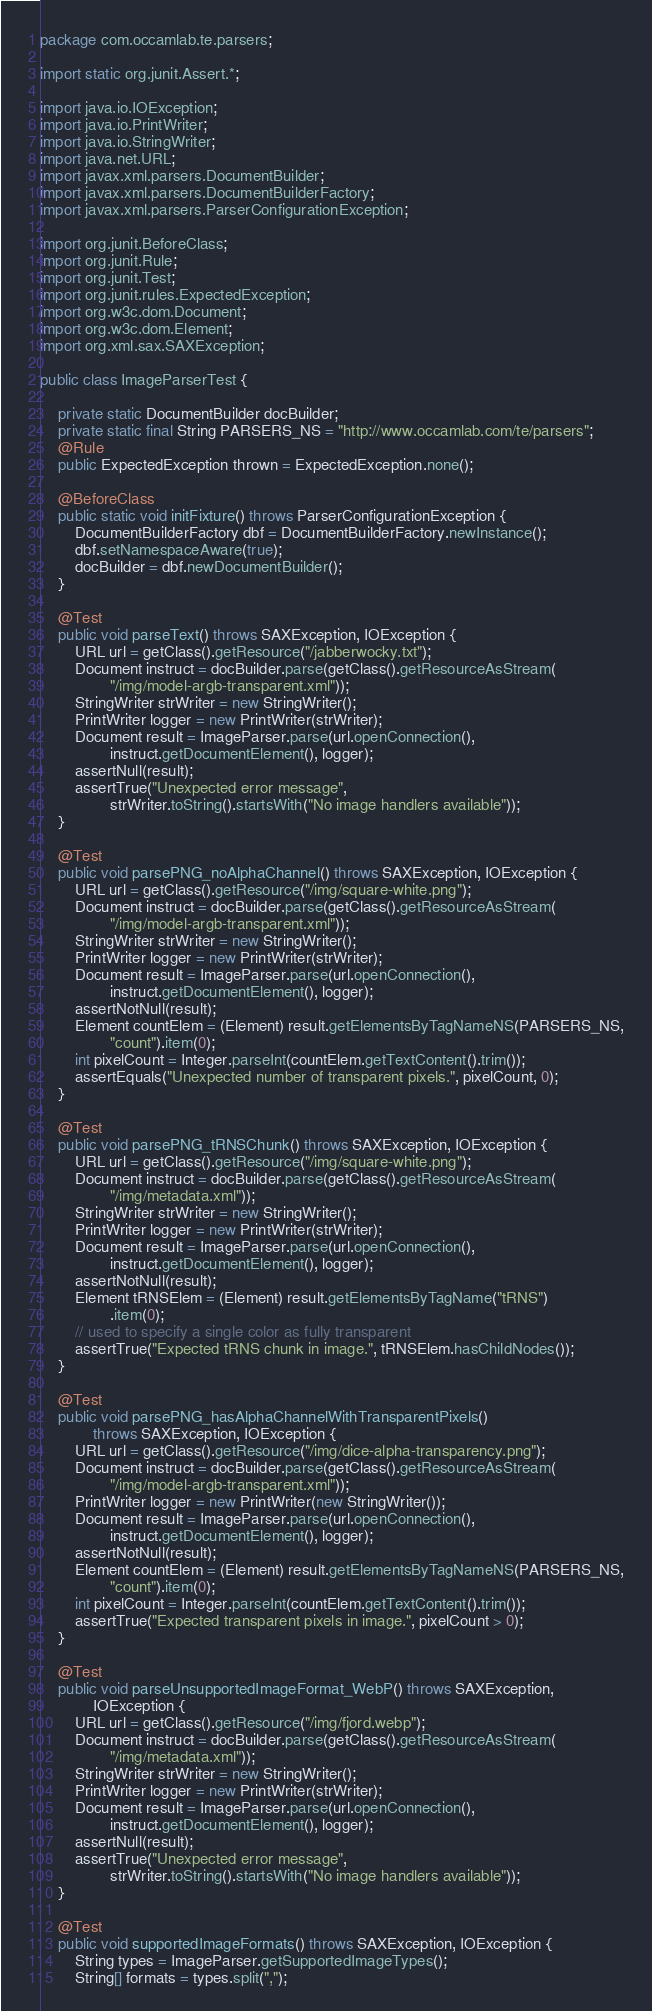Convert code to text. <code><loc_0><loc_0><loc_500><loc_500><_Java_>package com.occamlab.te.parsers;

import static org.junit.Assert.*;

import java.io.IOException;
import java.io.PrintWriter;
import java.io.StringWriter;
import java.net.URL;
import javax.xml.parsers.DocumentBuilder;
import javax.xml.parsers.DocumentBuilderFactory;
import javax.xml.parsers.ParserConfigurationException;

import org.junit.BeforeClass;
import org.junit.Rule;
import org.junit.Test;
import org.junit.rules.ExpectedException;
import org.w3c.dom.Document;
import org.w3c.dom.Element;
import org.xml.sax.SAXException;

public class ImageParserTest {

    private static DocumentBuilder docBuilder;
    private static final String PARSERS_NS = "http://www.occamlab.com/te/parsers";
    @Rule
    public ExpectedException thrown = ExpectedException.none();

    @BeforeClass
    public static void initFixture() throws ParserConfigurationException {
        DocumentBuilderFactory dbf = DocumentBuilderFactory.newInstance();
        dbf.setNamespaceAware(true);
        docBuilder = dbf.newDocumentBuilder();
    }

    @Test
    public void parseText() throws SAXException, IOException {
        URL url = getClass().getResource("/jabberwocky.txt");
        Document instruct = docBuilder.parse(getClass().getResourceAsStream(
                "/img/model-argb-transparent.xml"));
        StringWriter strWriter = new StringWriter();
        PrintWriter logger = new PrintWriter(strWriter);
        Document result = ImageParser.parse(url.openConnection(),
                instruct.getDocumentElement(), logger);
        assertNull(result);
        assertTrue("Unexpected error message",
                strWriter.toString().startsWith("No image handlers available"));
    }

    @Test
    public void parsePNG_noAlphaChannel() throws SAXException, IOException {
        URL url = getClass().getResource("/img/square-white.png");
        Document instruct = docBuilder.parse(getClass().getResourceAsStream(
                "/img/model-argb-transparent.xml"));
        StringWriter strWriter = new StringWriter();
        PrintWriter logger = new PrintWriter(strWriter);
        Document result = ImageParser.parse(url.openConnection(),
                instruct.getDocumentElement(), logger);
        assertNotNull(result);
        Element countElem = (Element) result.getElementsByTagNameNS(PARSERS_NS,
                "count").item(0);
        int pixelCount = Integer.parseInt(countElem.getTextContent().trim());
        assertEquals("Unexpected number of transparent pixels.", pixelCount, 0);
    }

    @Test
    public void parsePNG_tRNSChunk() throws SAXException, IOException {
        URL url = getClass().getResource("/img/square-white.png");
        Document instruct = docBuilder.parse(getClass().getResourceAsStream(
                "/img/metadata.xml"));
        StringWriter strWriter = new StringWriter();
        PrintWriter logger = new PrintWriter(strWriter);
        Document result = ImageParser.parse(url.openConnection(),
                instruct.getDocumentElement(), logger);
        assertNotNull(result);
        Element tRNSElem = (Element) result.getElementsByTagName("tRNS")
                .item(0);
        // used to specify a single color as fully transparent
        assertTrue("Expected tRNS chunk in image.", tRNSElem.hasChildNodes());
    }

    @Test
    public void parsePNG_hasAlphaChannelWithTransparentPixels()
            throws SAXException, IOException {
        URL url = getClass().getResource("/img/dice-alpha-transparency.png");
        Document instruct = docBuilder.parse(getClass().getResourceAsStream(
                "/img/model-argb-transparent.xml"));
        PrintWriter logger = new PrintWriter(new StringWriter());
        Document result = ImageParser.parse(url.openConnection(),
                instruct.getDocumentElement(), logger);
        assertNotNull(result);
        Element countElem = (Element) result.getElementsByTagNameNS(PARSERS_NS,
                "count").item(0);
        int pixelCount = Integer.parseInt(countElem.getTextContent().trim());
        assertTrue("Expected transparent pixels in image.", pixelCount > 0);
    }

    @Test
    public void parseUnsupportedImageFormat_WebP() throws SAXException,
            IOException {
        URL url = getClass().getResource("/img/fjord.webp");
        Document instruct = docBuilder.parse(getClass().getResourceAsStream(
                "/img/metadata.xml"));
        StringWriter strWriter = new StringWriter();
        PrintWriter logger = new PrintWriter(strWriter);
        Document result = ImageParser.parse(url.openConnection(),
                instruct.getDocumentElement(), logger);
        assertNull(result);
        assertTrue("Unexpected error message",
                strWriter.toString().startsWith("No image handlers available"));
    }

    @Test
    public void supportedImageFormats() throws SAXException, IOException {
        String types = ImageParser.getSupportedImageTypes();
        String[] formats = types.split(",");</code> 